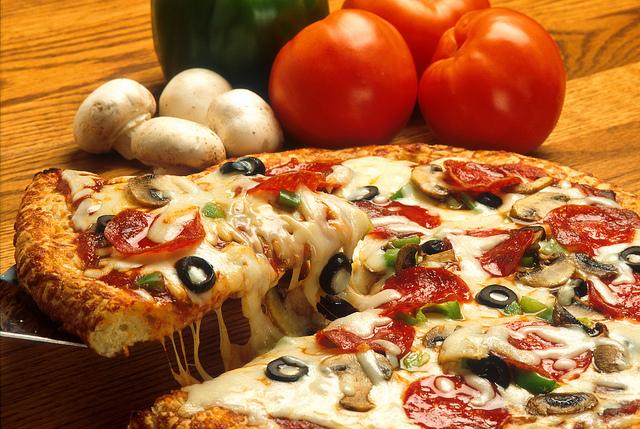Is this Digiorno?
Be succinct. No. Did someone take a piece?
Answer briefly. Yes. What is the vegetable on the pizza?
Quick response, please. Olives, peppers, mushrooms. What food is this?
Concise answer only. Pizza. What are the four objects next to the tomatoes?
Keep it brief. Mushrooms. Are there vegetables on the pizza?
Concise answer only. Yes. What shape is the pizza?
Quick response, please. Round. What meal does this represent?
Be succinct. Dinner. 